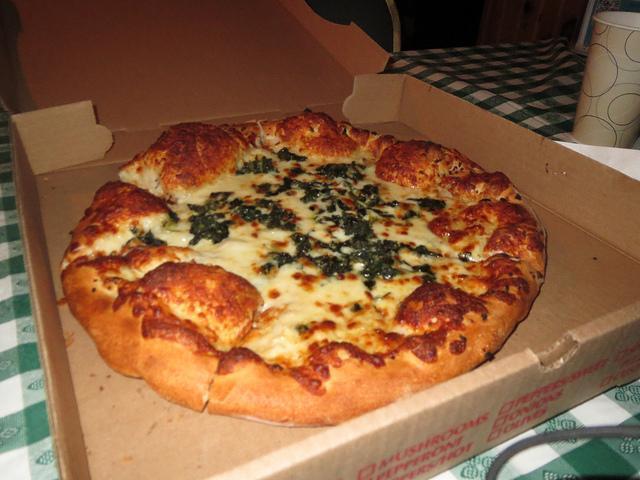How many cups are on the table?
Give a very brief answer. 1. How many dining tables are in the picture?
Give a very brief answer. 2. How many cups can you see?
Give a very brief answer. 1. How many people are wearing glasses?
Give a very brief answer. 0. 